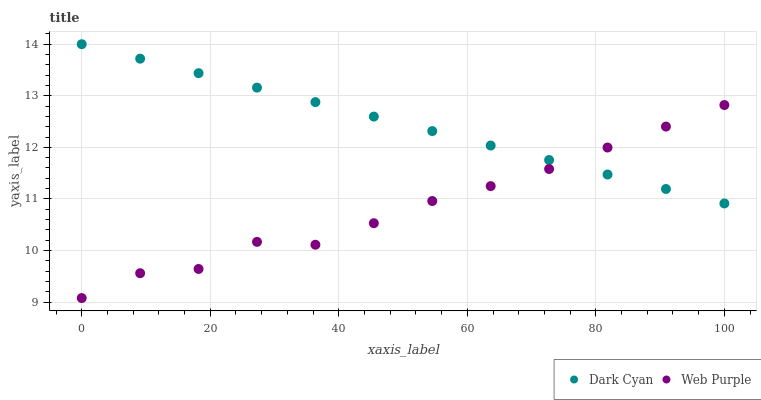Does Web Purple have the minimum area under the curve?
Answer yes or no. Yes. Does Dark Cyan have the maximum area under the curve?
Answer yes or no. Yes. Does Web Purple have the maximum area under the curve?
Answer yes or no. No. Is Dark Cyan the smoothest?
Answer yes or no. Yes. Is Web Purple the roughest?
Answer yes or no. Yes. Is Web Purple the smoothest?
Answer yes or no. No. Does Web Purple have the lowest value?
Answer yes or no. Yes. Does Dark Cyan have the highest value?
Answer yes or no. Yes. Does Web Purple have the highest value?
Answer yes or no. No. Does Web Purple intersect Dark Cyan?
Answer yes or no. Yes. Is Web Purple less than Dark Cyan?
Answer yes or no. No. Is Web Purple greater than Dark Cyan?
Answer yes or no. No. 